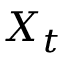<formula> <loc_0><loc_0><loc_500><loc_500>X _ { t }</formula> 